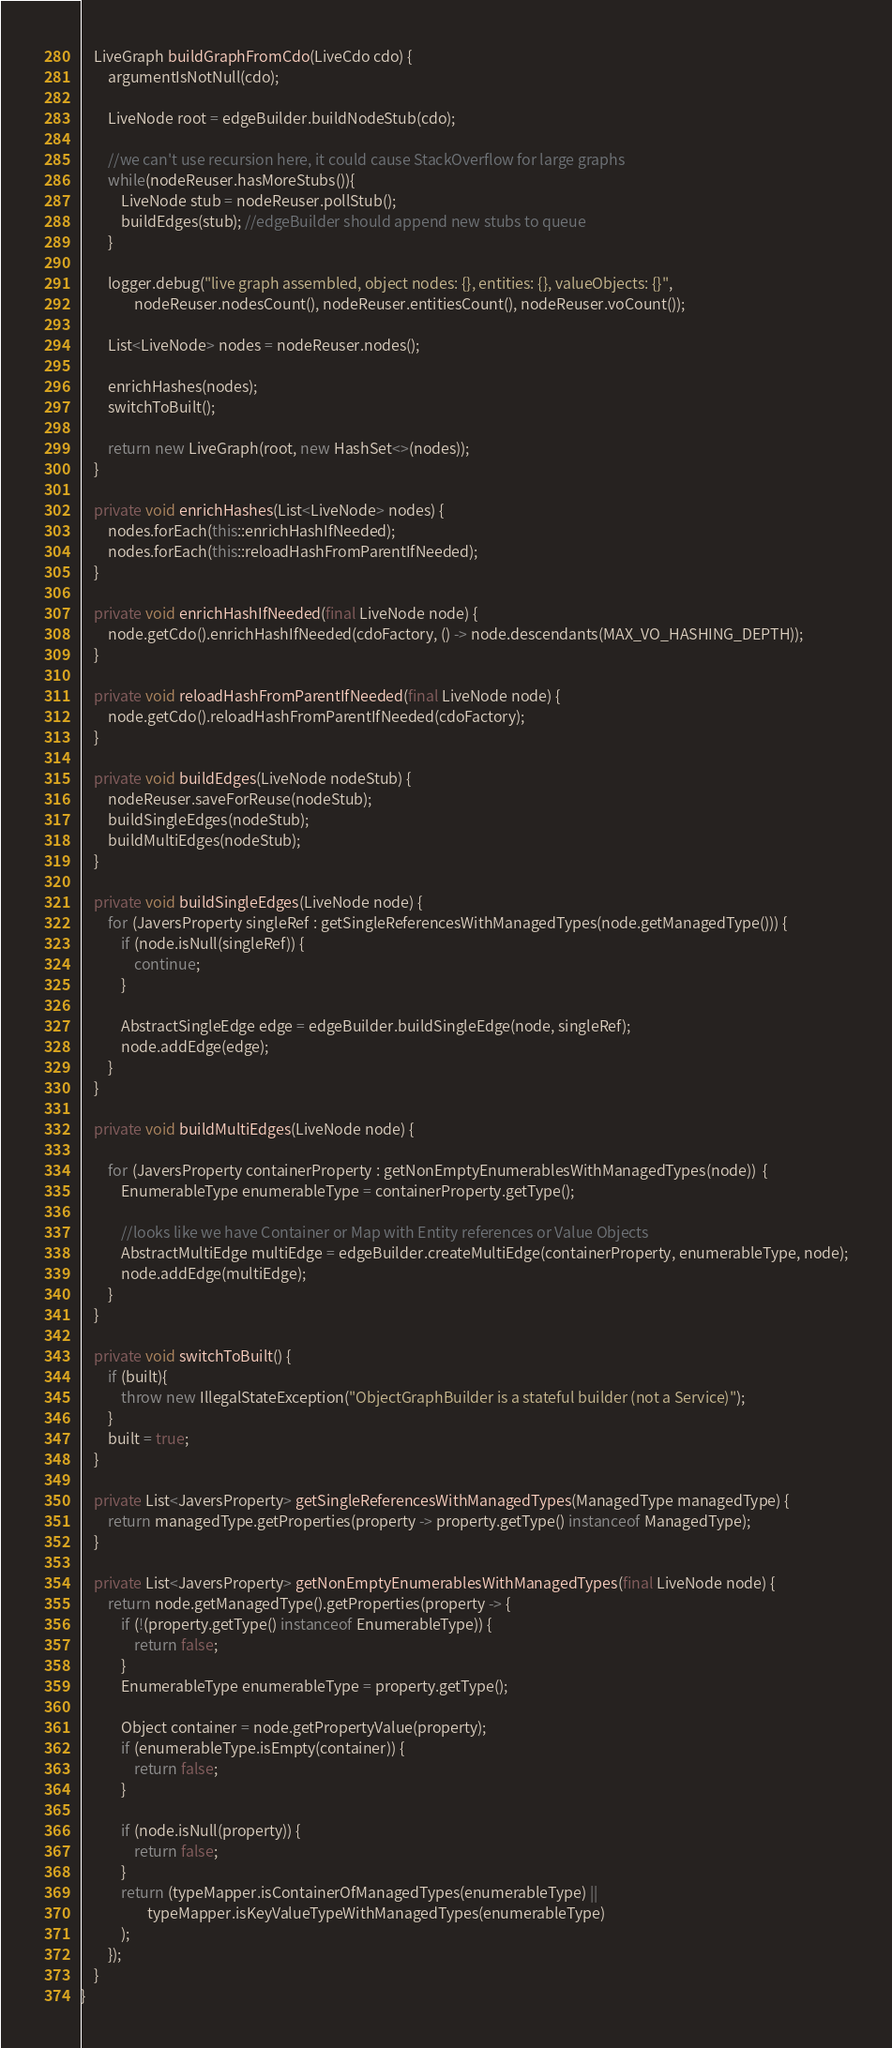<code> <loc_0><loc_0><loc_500><loc_500><_Java_>    LiveGraph buildGraphFromCdo(LiveCdo cdo) {
        argumentIsNotNull(cdo);

        LiveNode root = edgeBuilder.buildNodeStub(cdo);

        //we can't use recursion here, it could cause StackOverflow for large graphs
        while(nodeReuser.hasMoreStubs()){
            LiveNode stub = nodeReuser.pollStub();
            buildEdges(stub); //edgeBuilder should append new stubs to queue
        }

        logger.debug("live graph assembled, object nodes: {}, entities: {}, valueObjects: {}",
                nodeReuser.nodesCount(), nodeReuser.entitiesCount(), nodeReuser.voCount());

        List<LiveNode> nodes = nodeReuser.nodes();

        enrichHashes(nodes);
        switchToBuilt();

        return new LiveGraph(root, new HashSet<>(nodes));
    }

    private void enrichHashes(List<LiveNode> nodes) {
        nodes.forEach(this::enrichHashIfNeeded);
        nodes.forEach(this::reloadHashFromParentIfNeeded);
    }

    private void enrichHashIfNeeded(final LiveNode node) {
        node.getCdo().enrichHashIfNeeded(cdoFactory, () -> node.descendants(MAX_VO_HASHING_DEPTH));
    }

    private void reloadHashFromParentIfNeeded(final LiveNode node) {
        node.getCdo().reloadHashFromParentIfNeeded(cdoFactory);
    }

    private void buildEdges(LiveNode nodeStub) {
        nodeReuser.saveForReuse(nodeStub);
        buildSingleEdges(nodeStub);
        buildMultiEdges(nodeStub);
    }

    private void buildSingleEdges(LiveNode node) {
        for (JaversProperty singleRef : getSingleReferencesWithManagedTypes(node.getManagedType())) {
            if (node.isNull(singleRef)) {
                continue;
            }

            AbstractSingleEdge edge = edgeBuilder.buildSingleEdge(node, singleRef);
            node.addEdge(edge);
        }
    }

    private void buildMultiEdges(LiveNode node) {

        for (JaversProperty containerProperty : getNonEmptyEnumerablesWithManagedTypes(node))  {
            EnumerableType enumerableType = containerProperty.getType();

            //looks like we have Container or Map with Entity references or Value Objects
            AbstractMultiEdge multiEdge = edgeBuilder.createMultiEdge(containerProperty, enumerableType, node);
            node.addEdge(multiEdge);
        }
    }

    private void switchToBuilt() {
        if (built){
            throw new IllegalStateException("ObjectGraphBuilder is a stateful builder (not a Service)");
        }
        built = true;
    }

    private List<JaversProperty> getSingleReferencesWithManagedTypes(ManagedType managedType) {
        return managedType.getProperties(property -> property.getType() instanceof ManagedType);
    }

    private List<JaversProperty> getNonEmptyEnumerablesWithManagedTypes(final LiveNode node) {
        return node.getManagedType().getProperties(property -> {
            if (!(property.getType() instanceof EnumerableType)) {
                return false;
            }
            EnumerableType enumerableType = property.getType();

            Object container = node.getPropertyValue(property);
            if (enumerableType.isEmpty(container)) {
                return false;
            }

            if (node.isNull(property)) {
                return false;
            }
            return (typeMapper.isContainerOfManagedTypes(enumerableType) ||
                    typeMapper.isKeyValueTypeWithManagedTypes(enumerableType)
            );
        });
    }
}</code> 